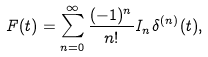Convert formula to latex. <formula><loc_0><loc_0><loc_500><loc_500>F ( t ) = \sum _ { n = 0 } ^ { \infty } \frac { ( - 1 ) ^ { n } } { n ! } I _ { n } \delta ^ { ( n ) } ( t ) ,</formula> 